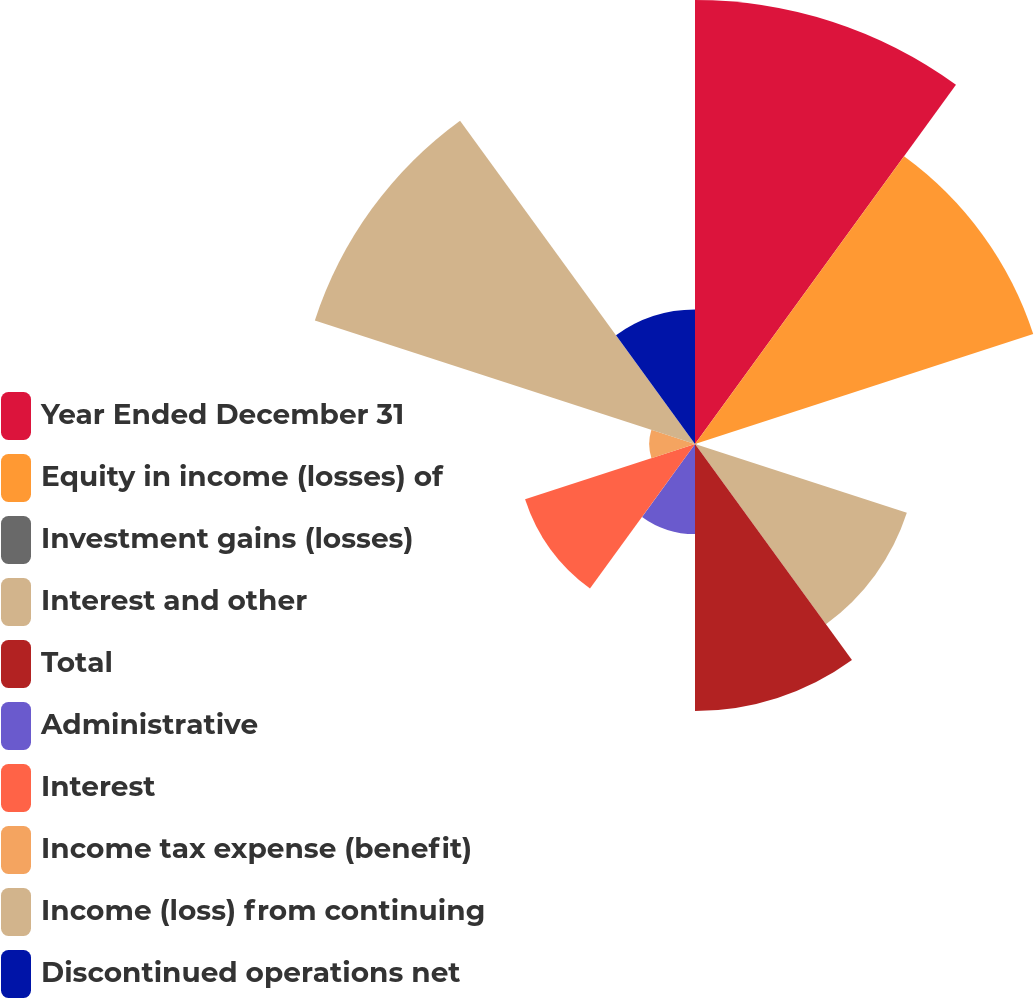Convert chart to OTSL. <chart><loc_0><loc_0><loc_500><loc_500><pie_chart><fcel>Year Ended December 31<fcel>Equity in income (losses) of<fcel>Investment gains (losses)<fcel>Interest and other<fcel>Total<fcel>Administrative<fcel>Interest<fcel>Income tax expense (benefit)<fcel>Income (loss) from continuing<fcel>Discontinued operations net<nl><fcel>20.75%<fcel>16.62%<fcel>0.08%<fcel>10.41%<fcel>12.48%<fcel>4.21%<fcel>8.35%<fcel>2.14%<fcel>18.68%<fcel>6.28%<nl></chart> 